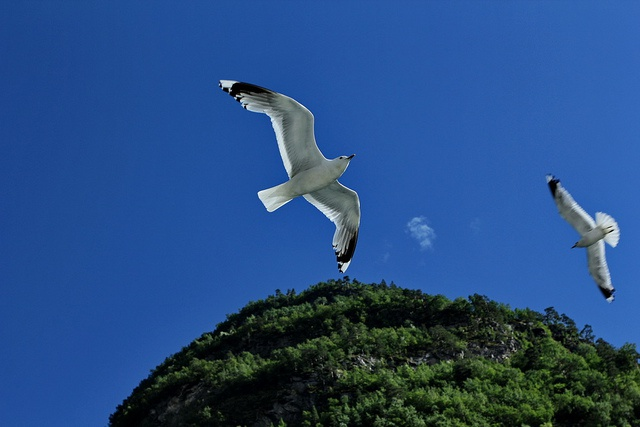Describe the objects in this image and their specific colors. I can see bird in darkblue, gray, blue, darkgray, and black tones and bird in darkblue, gray, darkgray, lightgray, and black tones in this image. 